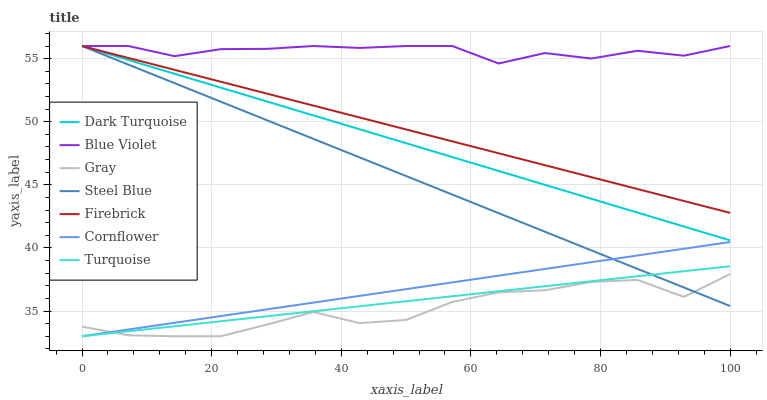Does Turquoise have the minimum area under the curve?
Answer yes or no. No. Does Turquoise have the maximum area under the curve?
Answer yes or no. No. Is Turquoise the smoothest?
Answer yes or no. No. Is Turquoise the roughest?
Answer yes or no. No. Does Dark Turquoise have the lowest value?
Answer yes or no. No. Does Turquoise have the highest value?
Answer yes or no. No. Is Gray less than Firebrick?
Answer yes or no. Yes. Is Blue Violet greater than Gray?
Answer yes or no. Yes. Does Gray intersect Firebrick?
Answer yes or no. No. 